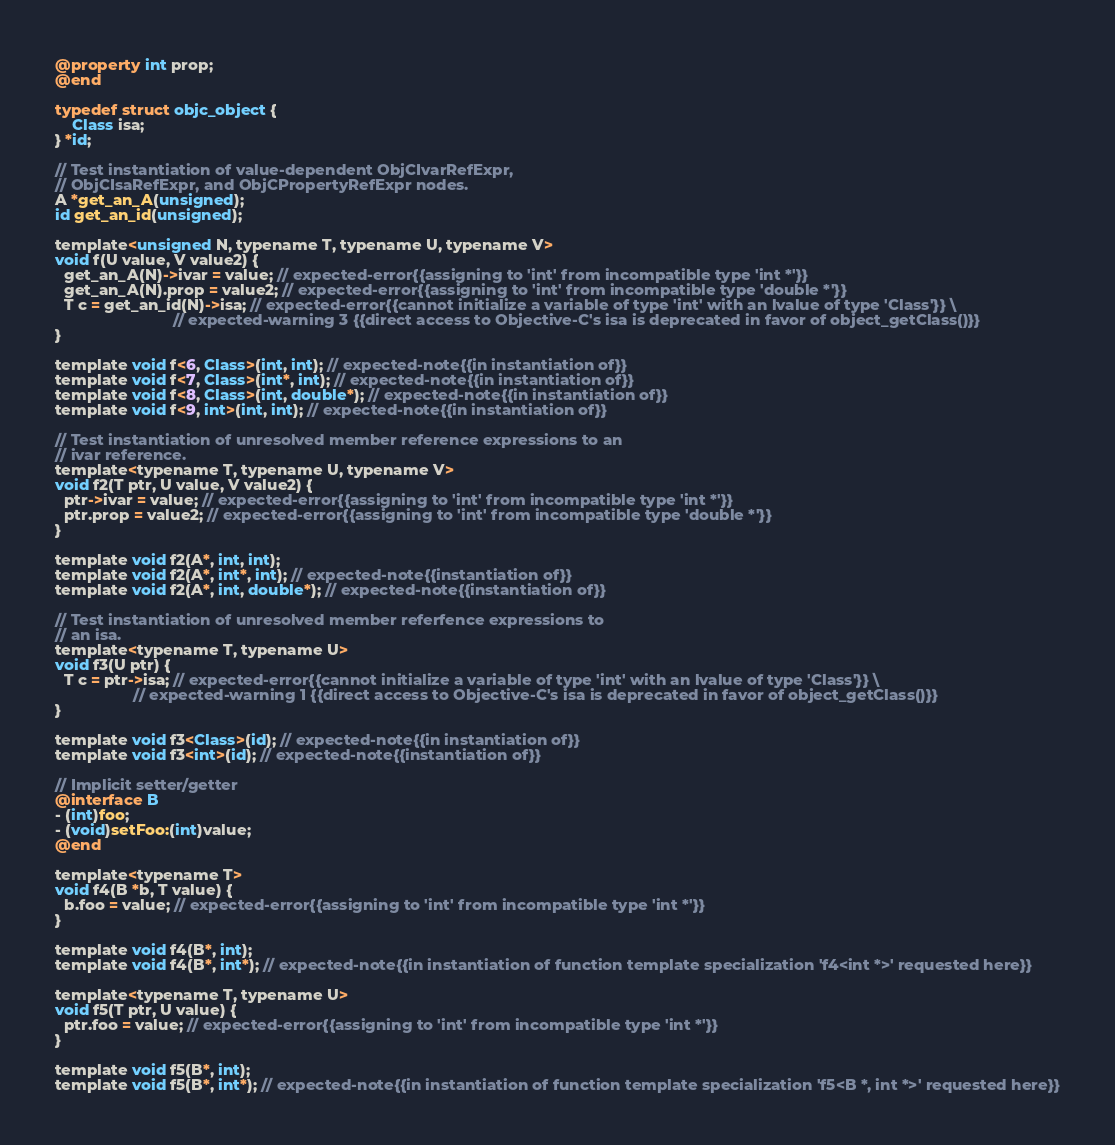Convert code to text. <code><loc_0><loc_0><loc_500><loc_500><_ObjectiveC_>@property int prop;
@end

typedef struct objc_object {
    Class isa;
} *id;

// Test instantiation of value-dependent ObjCIvarRefExpr,
// ObjCIsaRefExpr, and ObjCPropertyRefExpr nodes.
A *get_an_A(unsigned);
id get_an_id(unsigned);

template<unsigned N, typename T, typename U, typename V>
void f(U value, V value2) {
  get_an_A(N)->ivar = value; // expected-error{{assigning to 'int' from incompatible type 'int *'}}
  get_an_A(N).prop = value2; // expected-error{{assigning to 'int' from incompatible type 'double *'}}
  T c = get_an_id(N)->isa; // expected-error{{cannot initialize a variable of type 'int' with an lvalue of type 'Class'}} \
                           // expected-warning 3 {{direct access to Objective-C's isa is deprecated in favor of object_getClass()}}
}

template void f<6, Class>(int, int); // expected-note{{in instantiation of}}
template void f<7, Class>(int*, int); // expected-note{{in instantiation of}}
template void f<8, Class>(int, double*); // expected-note{{in instantiation of}}
template void f<9, int>(int, int); // expected-note{{in instantiation of}}

// Test instantiation of unresolved member reference expressions to an
// ivar reference.
template<typename T, typename U, typename V>
void f2(T ptr, U value, V value2) {
  ptr->ivar = value; // expected-error{{assigning to 'int' from incompatible type 'int *'}}
  ptr.prop = value2; // expected-error{{assigning to 'int' from incompatible type 'double *'}}
}

template void f2(A*, int, int);
template void f2(A*, int*, int); // expected-note{{instantiation of}}
template void f2(A*, int, double*); // expected-note{{instantiation of}}

// Test instantiation of unresolved member referfence expressions to
// an isa.
template<typename T, typename U>
void f3(U ptr) {
  T c = ptr->isa; // expected-error{{cannot initialize a variable of type 'int' with an lvalue of type 'Class'}} \
                  // expected-warning 1 {{direct access to Objective-C's isa is deprecated in favor of object_getClass()}}
}

template void f3<Class>(id); // expected-note{{in instantiation of}}
template void f3<int>(id); // expected-note{{instantiation of}}

// Implicit setter/getter
@interface B
- (int)foo;
- (void)setFoo:(int)value;
@end

template<typename T>
void f4(B *b, T value) {
  b.foo = value; // expected-error{{assigning to 'int' from incompatible type 'int *'}}
}

template void f4(B*, int);
template void f4(B*, int*); // expected-note{{in instantiation of function template specialization 'f4<int *>' requested here}}

template<typename T, typename U>
void f5(T ptr, U value) {
  ptr.foo = value; // expected-error{{assigning to 'int' from incompatible type 'int *'}}
}

template void f5(B*, int);
template void f5(B*, int*); // expected-note{{in instantiation of function template specialization 'f5<B *, int *>' requested here}}
</code> 